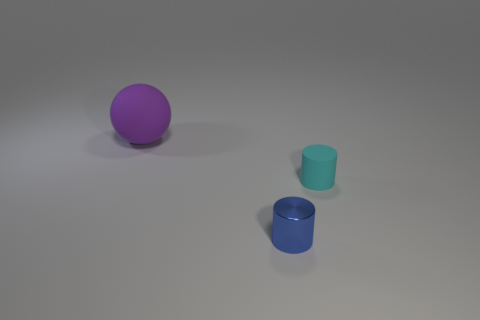Could you describe the colors and shapes of the objects in this image? Certainly! There are three objects in this image. Starting from the left, there's a purple sphere, which is a perfect 3D circle shape. Next, you'll see a cyan cylinder, which is shorter and appears to be a smaller container or a cup. Last, on the right, is a blue cylinder, which is taller and resembles a bigger cup or container. Each object has a matte finish with a hint of shine, giving them a subtle glow under the light. 